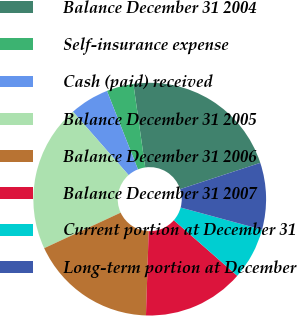Convert chart. <chart><loc_0><loc_0><loc_500><loc_500><pie_chart><fcel>Balance December 31 2004<fcel>Self-insurance expense<fcel>Cash (paid) received<fcel>Balance December 31 2005<fcel>Balance December 31 2006<fcel>Balance December 31 2007<fcel>Current portion at December 31<fcel>Long-term portion at December<nl><fcel>22.19%<fcel>3.75%<fcel>5.48%<fcel>20.45%<fcel>17.56%<fcel>14.07%<fcel>7.22%<fcel>9.27%<nl></chart> 